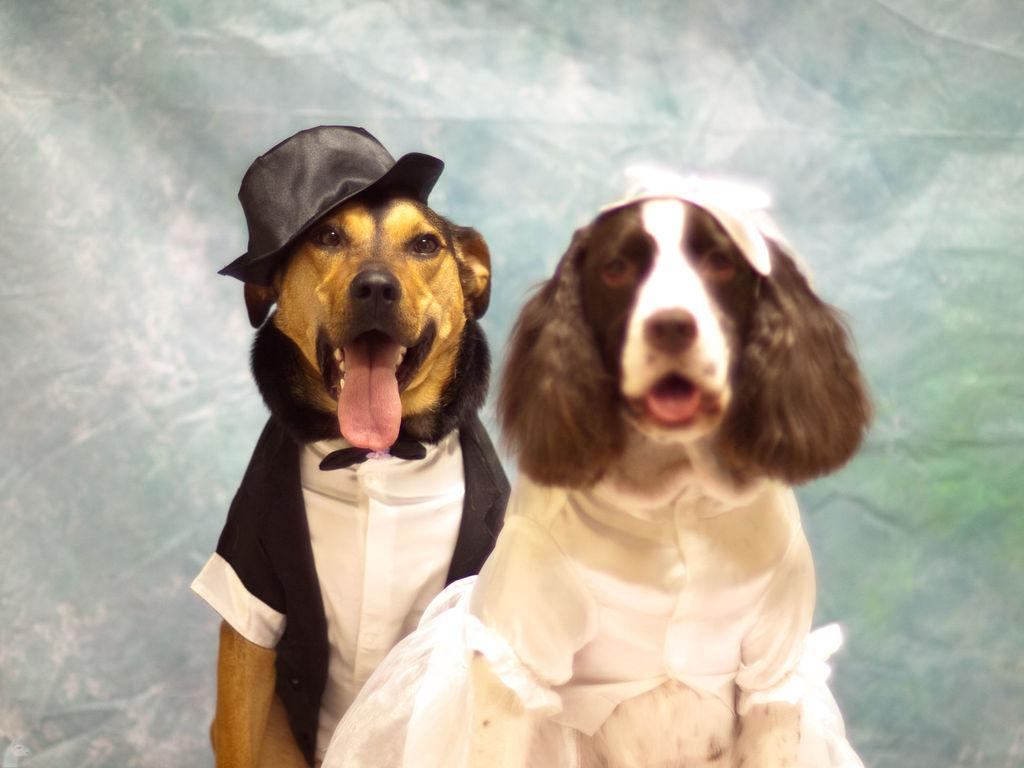How many dogs are present in the image? There are two dogs in the image. What are the dogs wearing? The dogs are wearing costumes. Can you describe the background of the image? There is a cloth-like element in the background of the image. What type of button can be seen on the dogs' costumes in the image? There are no buttons visible on the dogs' costumes in the image. Are the dogs driving a vehicle in the image? No, the dogs are not driving a vehicle in the image. 